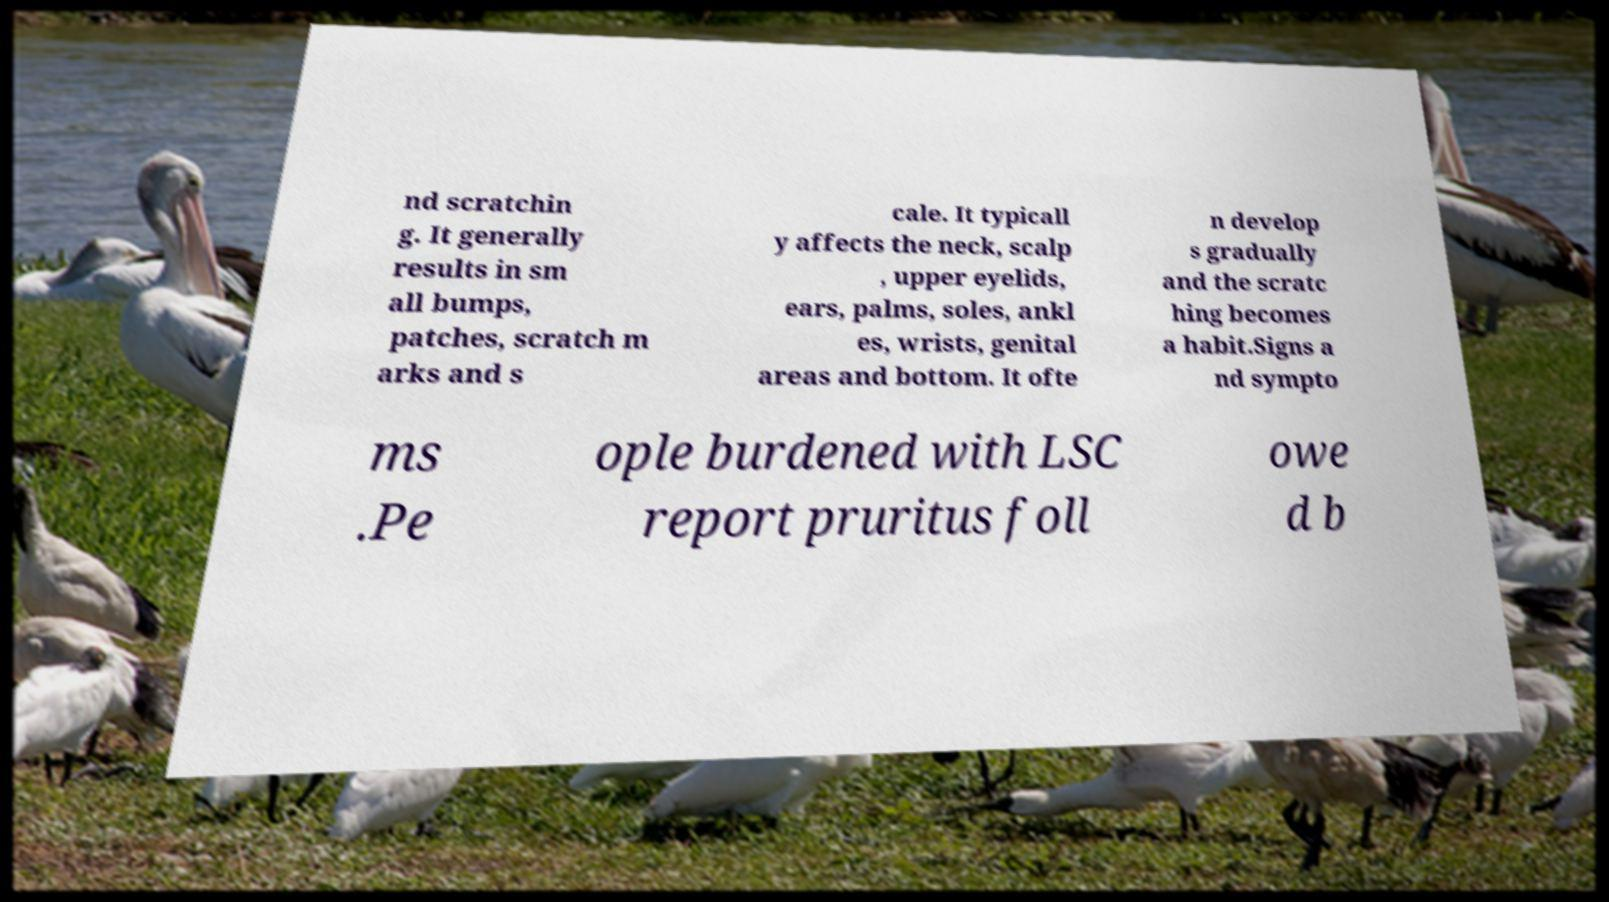For documentation purposes, I need the text within this image transcribed. Could you provide that? nd scratchin g. It generally results in sm all bumps, patches, scratch m arks and s cale. It typicall y affects the neck, scalp , upper eyelids, ears, palms, soles, ankl es, wrists, genital areas and bottom. It ofte n develop s gradually and the scratc hing becomes a habit.Signs a nd sympto ms .Pe ople burdened with LSC report pruritus foll owe d b 